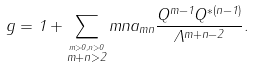<formula> <loc_0><loc_0><loc_500><loc_500>g = 1 + \sum _ { \stackrel { m > 0 , n > 0 } { m + n > 2 } } m n a _ { m n } \frac { Q ^ { m - 1 } Q ^ { * ( n - 1 ) } } { \Lambda ^ { m + n - 2 } } .</formula> 